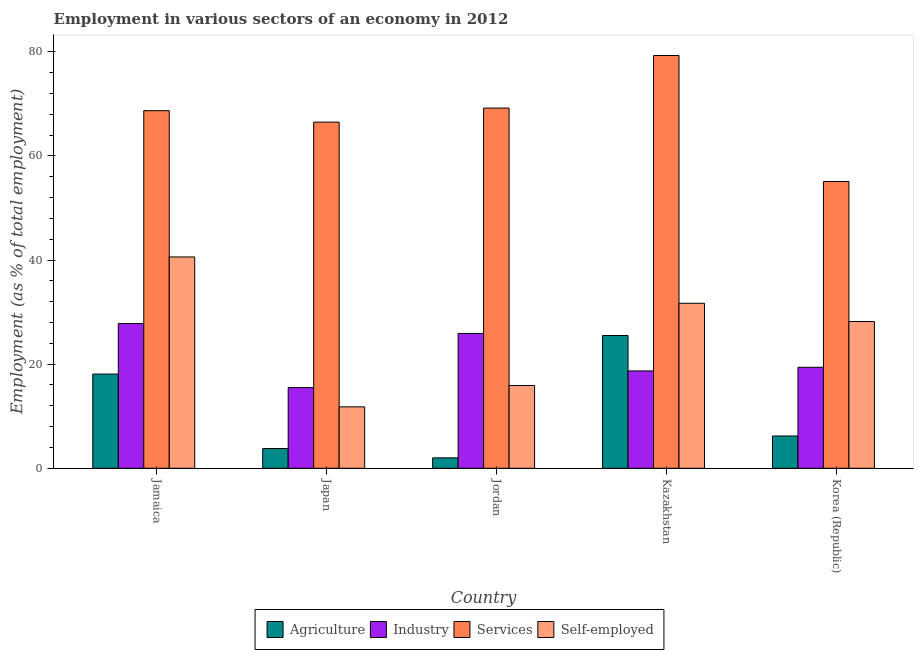How many groups of bars are there?
Keep it short and to the point. 5. Are the number of bars per tick equal to the number of legend labels?
Keep it short and to the point. Yes. How many bars are there on the 5th tick from the right?
Offer a terse response. 4. What is the label of the 1st group of bars from the left?
Make the answer very short. Jamaica. In how many cases, is the number of bars for a given country not equal to the number of legend labels?
Your answer should be compact. 0. What is the percentage of workers in services in Jordan?
Offer a very short reply. 69.2. Across all countries, what is the maximum percentage of workers in services?
Give a very brief answer. 79.3. Across all countries, what is the minimum percentage of workers in industry?
Provide a short and direct response. 15.5. In which country was the percentage of workers in services maximum?
Provide a succinct answer. Kazakhstan. What is the total percentage of self employed workers in the graph?
Your answer should be compact. 128.2. What is the difference between the percentage of workers in industry in Japan and that in Jordan?
Your answer should be compact. -10.4. What is the difference between the percentage of workers in industry in Jordan and the percentage of workers in agriculture in Jamaica?
Your answer should be compact. 7.8. What is the average percentage of self employed workers per country?
Provide a short and direct response. 25.64. What is the difference between the percentage of workers in industry and percentage of workers in agriculture in Japan?
Your response must be concise. 11.7. In how many countries, is the percentage of workers in services greater than 36 %?
Provide a succinct answer. 5. What is the ratio of the percentage of workers in industry in Jamaica to that in Jordan?
Keep it short and to the point. 1.07. What is the difference between the highest and the second highest percentage of self employed workers?
Offer a terse response. 8.9. What is the difference between the highest and the lowest percentage of workers in industry?
Ensure brevity in your answer.  12.3. In how many countries, is the percentage of workers in agriculture greater than the average percentage of workers in agriculture taken over all countries?
Keep it short and to the point. 2. Is the sum of the percentage of workers in industry in Jamaica and Kazakhstan greater than the maximum percentage of self employed workers across all countries?
Keep it short and to the point. Yes. Is it the case that in every country, the sum of the percentage of workers in services and percentage of workers in agriculture is greater than the sum of percentage of self employed workers and percentage of workers in industry?
Offer a very short reply. No. What does the 2nd bar from the left in Japan represents?
Your response must be concise. Industry. What does the 4th bar from the right in Jordan represents?
Ensure brevity in your answer.  Agriculture. Is it the case that in every country, the sum of the percentage of workers in agriculture and percentage of workers in industry is greater than the percentage of workers in services?
Your answer should be very brief. No. How many bars are there?
Offer a terse response. 20. Does the graph contain any zero values?
Make the answer very short. No. Where does the legend appear in the graph?
Make the answer very short. Bottom center. How many legend labels are there?
Make the answer very short. 4. What is the title of the graph?
Provide a succinct answer. Employment in various sectors of an economy in 2012. What is the label or title of the Y-axis?
Your response must be concise. Employment (as % of total employment). What is the Employment (as % of total employment) in Agriculture in Jamaica?
Your answer should be very brief. 18.1. What is the Employment (as % of total employment) of Industry in Jamaica?
Give a very brief answer. 27.8. What is the Employment (as % of total employment) in Services in Jamaica?
Give a very brief answer. 68.7. What is the Employment (as % of total employment) in Self-employed in Jamaica?
Provide a succinct answer. 40.6. What is the Employment (as % of total employment) in Agriculture in Japan?
Ensure brevity in your answer.  3.8. What is the Employment (as % of total employment) of Services in Japan?
Provide a short and direct response. 66.5. What is the Employment (as % of total employment) of Self-employed in Japan?
Make the answer very short. 11.8. What is the Employment (as % of total employment) in Agriculture in Jordan?
Your response must be concise. 2. What is the Employment (as % of total employment) of Industry in Jordan?
Offer a terse response. 25.9. What is the Employment (as % of total employment) in Services in Jordan?
Offer a terse response. 69.2. What is the Employment (as % of total employment) of Self-employed in Jordan?
Provide a succinct answer. 15.9. What is the Employment (as % of total employment) in Industry in Kazakhstan?
Keep it short and to the point. 18.7. What is the Employment (as % of total employment) of Services in Kazakhstan?
Provide a succinct answer. 79.3. What is the Employment (as % of total employment) in Self-employed in Kazakhstan?
Ensure brevity in your answer.  31.7. What is the Employment (as % of total employment) in Agriculture in Korea (Republic)?
Offer a very short reply. 6.2. What is the Employment (as % of total employment) of Industry in Korea (Republic)?
Ensure brevity in your answer.  19.4. What is the Employment (as % of total employment) in Services in Korea (Republic)?
Ensure brevity in your answer.  55.1. What is the Employment (as % of total employment) in Self-employed in Korea (Republic)?
Your response must be concise. 28.2. Across all countries, what is the maximum Employment (as % of total employment) of Industry?
Ensure brevity in your answer.  27.8. Across all countries, what is the maximum Employment (as % of total employment) in Services?
Offer a very short reply. 79.3. Across all countries, what is the maximum Employment (as % of total employment) of Self-employed?
Ensure brevity in your answer.  40.6. Across all countries, what is the minimum Employment (as % of total employment) of Services?
Give a very brief answer. 55.1. Across all countries, what is the minimum Employment (as % of total employment) in Self-employed?
Ensure brevity in your answer.  11.8. What is the total Employment (as % of total employment) of Agriculture in the graph?
Make the answer very short. 55.6. What is the total Employment (as % of total employment) in Industry in the graph?
Give a very brief answer. 107.3. What is the total Employment (as % of total employment) of Services in the graph?
Offer a terse response. 338.8. What is the total Employment (as % of total employment) in Self-employed in the graph?
Provide a succinct answer. 128.2. What is the difference between the Employment (as % of total employment) in Agriculture in Jamaica and that in Japan?
Your response must be concise. 14.3. What is the difference between the Employment (as % of total employment) in Self-employed in Jamaica and that in Japan?
Your answer should be very brief. 28.8. What is the difference between the Employment (as % of total employment) in Agriculture in Jamaica and that in Jordan?
Offer a very short reply. 16.1. What is the difference between the Employment (as % of total employment) of Self-employed in Jamaica and that in Jordan?
Provide a succinct answer. 24.7. What is the difference between the Employment (as % of total employment) of Agriculture in Jamaica and that in Kazakhstan?
Make the answer very short. -7.4. What is the difference between the Employment (as % of total employment) of Industry in Jamaica and that in Kazakhstan?
Make the answer very short. 9.1. What is the difference between the Employment (as % of total employment) of Self-employed in Jamaica and that in Korea (Republic)?
Provide a succinct answer. 12.4. What is the difference between the Employment (as % of total employment) of Services in Japan and that in Jordan?
Keep it short and to the point. -2.7. What is the difference between the Employment (as % of total employment) of Self-employed in Japan and that in Jordan?
Ensure brevity in your answer.  -4.1. What is the difference between the Employment (as % of total employment) in Agriculture in Japan and that in Kazakhstan?
Give a very brief answer. -21.7. What is the difference between the Employment (as % of total employment) of Industry in Japan and that in Kazakhstan?
Offer a terse response. -3.2. What is the difference between the Employment (as % of total employment) in Services in Japan and that in Kazakhstan?
Your answer should be very brief. -12.8. What is the difference between the Employment (as % of total employment) in Self-employed in Japan and that in Kazakhstan?
Offer a very short reply. -19.9. What is the difference between the Employment (as % of total employment) in Agriculture in Japan and that in Korea (Republic)?
Provide a short and direct response. -2.4. What is the difference between the Employment (as % of total employment) of Industry in Japan and that in Korea (Republic)?
Make the answer very short. -3.9. What is the difference between the Employment (as % of total employment) in Self-employed in Japan and that in Korea (Republic)?
Ensure brevity in your answer.  -16.4. What is the difference between the Employment (as % of total employment) in Agriculture in Jordan and that in Kazakhstan?
Keep it short and to the point. -23.5. What is the difference between the Employment (as % of total employment) of Self-employed in Jordan and that in Kazakhstan?
Provide a succinct answer. -15.8. What is the difference between the Employment (as % of total employment) in Agriculture in Jordan and that in Korea (Republic)?
Your answer should be compact. -4.2. What is the difference between the Employment (as % of total employment) in Industry in Jordan and that in Korea (Republic)?
Offer a terse response. 6.5. What is the difference between the Employment (as % of total employment) in Self-employed in Jordan and that in Korea (Republic)?
Offer a very short reply. -12.3. What is the difference between the Employment (as % of total employment) of Agriculture in Kazakhstan and that in Korea (Republic)?
Make the answer very short. 19.3. What is the difference between the Employment (as % of total employment) in Services in Kazakhstan and that in Korea (Republic)?
Your answer should be very brief. 24.2. What is the difference between the Employment (as % of total employment) of Self-employed in Kazakhstan and that in Korea (Republic)?
Offer a very short reply. 3.5. What is the difference between the Employment (as % of total employment) in Agriculture in Jamaica and the Employment (as % of total employment) in Industry in Japan?
Ensure brevity in your answer.  2.6. What is the difference between the Employment (as % of total employment) in Agriculture in Jamaica and the Employment (as % of total employment) in Services in Japan?
Your answer should be compact. -48.4. What is the difference between the Employment (as % of total employment) in Industry in Jamaica and the Employment (as % of total employment) in Services in Japan?
Keep it short and to the point. -38.7. What is the difference between the Employment (as % of total employment) of Industry in Jamaica and the Employment (as % of total employment) of Self-employed in Japan?
Ensure brevity in your answer.  16. What is the difference between the Employment (as % of total employment) in Services in Jamaica and the Employment (as % of total employment) in Self-employed in Japan?
Provide a short and direct response. 56.9. What is the difference between the Employment (as % of total employment) of Agriculture in Jamaica and the Employment (as % of total employment) of Services in Jordan?
Your response must be concise. -51.1. What is the difference between the Employment (as % of total employment) of Agriculture in Jamaica and the Employment (as % of total employment) of Self-employed in Jordan?
Keep it short and to the point. 2.2. What is the difference between the Employment (as % of total employment) in Industry in Jamaica and the Employment (as % of total employment) in Services in Jordan?
Your answer should be compact. -41.4. What is the difference between the Employment (as % of total employment) of Services in Jamaica and the Employment (as % of total employment) of Self-employed in Jordan?
Offer a very short reply. 52.8. What is the difference between the Employment (as % of total employment) in Agriculture in Jamaica and the Employment (as % of total employment) in Industry in Kazakhstan?
Provide a succinct answer. -0.6. What is the difference between the Employment (as % of total employment) in Agriculture in Jamaica and the Employment (as % of total employment) in Services in Kazakhstan?
Your response must be concise. -61.2. What is the difference between the Employment (as % of total employment) of Industry in Jamaica and the Employment (as % of total employment) of Services in Kazakhstan?
Ensure brevity in your answer.  -51.5. What is the difference between the Employment (as % of total employment) in Services in Jamaica and the Employment (as % of total employment) in Self-employed in Kazakhstan?
Your answer should be very brief. 37. What is the difference between the Employment (as % of total employment) of Agriculture in Jamaica and the Employment (as % of total employment) of Services in Korea (Republic)?
Provide a succinct answer. -37. What is the difference between the Employment (as % of total employment) in Agriculture in Jamaica and the Employment (as % of total employment) in Self-employed in Korea (Republic)?
Make the answer very short. -10.1. What is the difference between the Employment (as % of total employment) of Industry in Jamaica and the Employment (as % of total employment) of Services in Korea (Republic)?
Your response must be concise. -27.3. What is the difference between the Employment (as % of total employment) of Services in Jamaica and the Employment (as % of total employment) of Self-employed in Korea (Republic)?
Your answer should be compact. 40.5. What is the difference between the Employment (as % of total employment) in Agriculture in Japan and the Employment (as % of total employment) in Industry in Jordan?
Ensure brevity in your answer.  -22.1. What is the difference between the Employment (as % of total employment) in Agriculture in Japan and the Employment (as % of total employment) in Services in Jordan?
Offer a terse response. -65.4. What is the difference between the Employment (as % of total employment) in Industry in Japan and the Employment (as % of total employment) in Services in Jordan?
Offer a terse response. -53.7. What is the difference between the Employment (as % of total employment) of Industry in Japan and the Employment (as % of total employment) of Self-employed in Jordan?
Provide a succinct answer. -0.4. What is the difference between the Employment (as % of total employment) in Services in Japan and the Employment (as % of total employment) in Self-employed in Jordan?
Provide a short and direct response. 50.6. What is the difference between the Employment (as % of total employment) in Agriculture in Japan and the Employment (as % of total employment) in Industry in Kazakhstan?
Your response must be concise. -14.9. What is the difference between the Employment (as % of total employment) of Agriculture in Japan and the Employment (as % of total employment) of Services in Kazakhstan?
Offer a terse response. -75.5. What is the difference between the Employment (as % of total employment) in Agriculture in Japan and the Employment (as % of total employment) in Self-employed in Kazakhstan?
Make the answer very short. -27.9. What is the difference between the Employment (as % of total employment) in Industry in Japan and the Employment (as % of total employment) in Services in Kazakhstan?
Keep it short and to the point. -63.8. What is the difference between the Employment (as % of total employment) of Industry in Japan and the Employment (as % of total employment) of Self-employed in Kazakhstan?
Keep it short and to the point. -16.2. What is the difference between the Employment (as % of total employment) in Services in Japan and the Employment (as % of total employment) in Self-employed in Kazakhstan?
Your answer should be very brief. 34.8. What is the difference between the Employment (as % of total employment) in Agriculture in Japan and the Employment (as % of total employment) in Industry in Korea (Republic)?
Offer a very short reply. -15.6. What is the difference between the Employment (as % of total employment) in Agriculture in Japan and the Employment (as % of total employment) in Services in Korea (Republic)?
Make the answer very short. -51.3. What is the difference between the Employment (as % of total employment) in Agriculture in Japan and the Employment (as % of total employment) in Self-employed in Korea (Republic)?
Give a very brief answer. -24.4. What is the difference between the Employment (as % of total employment) in Industry in Japan and the Employment (as % of total employment) in Services in Korea (Republic)?
Provide a succinct answer. -39.6. What is the difference between the Employment (as % of total employment) of Services in Japan and the Employment (as % of total employment) of Self-employed in Korea (Republic)?
Make the answer very short. 38.3. What is the difference between the Employment (as % of total employment) in Agriculture in Jordan and the Employment (as % of total employment) in Industry in Kazakhstan?
Your answer should be very brief. -16.7. What is the difference between the Employment (as % of total employment) of Agriculture in Jordan and the Employment (as % of total employment) of Services in Kazakhstan?
Offer a very short reply. -77.3. What is the difference between the Employment (as % of total employment) in Agriculture in Jordan and the Employment (as % of total employment) in Self-employed in Kazakhstan?
Your response must be concise. -29.7. What is the difference between the Employment (as % of total employment) in Industry in Jordan and the Employment (as % of total employment) in Services in Kazakhstan?
Keep it short and to the point. -53.4. What is the difference between the Employment (as % of total employment) of Services in Jordan and the Employment (as % of total employment) of Self-employed in Kazakhstan?
Provide a succinct answer. 37.5. What is the difference between the Employment (as % of total employment) in Agriculture in Jordan and the Employment (as % of total employment) in Industry in Korea (Republic)?
Your answer should be very brief. -17.4. What is the difference between the Employment (as % of total employment) in Agriculture in Jordan and the Employment (as % of total employment) in Services in Korea (Republic)?
Make the answer very short. -53.1. What is the difference between the Employment (as % of total employment) in Agriculture in Jordan and the Employment (as % of total employment) in Self-employed in Korea (Republic)?
Your response must be concise. -26.2. What is the difference between the Employment (as % of total employment) in Industry in Jordan and the Employment (as % of total employment) in Services in Korea (Republic)?
Your answer should be very brief. -29.2. What is the difference between the Employment (as % of total employment) of Agriculture in Kazakhstan and the Employment (as % of total employment) of Services in Korea (Republic)?
Give a very brief answer. -29.6. What is the difference between the Employment (as % of total employment) of Industry in Kazakhstan and the Employment (as % of total employment) of Services in Korea (Republic)?
Provide a succinct answer. -36.4. What is the difference between the Employment (as % of total employment) of Industry in Kazakhstan and the Employment (as % of total employment) of Self-employed in Korea (Republic)?
Your answer should be compact. -9.5. What is the difference between the Employment (as % of total employment) of Services in Kazakhstan and the Employment (as % of total employment) of Self-employed in Korea (Republic)?
Offer a terse response. 51.1. What is the average Employment (as % of total employment) in Agriculture per country?
Offer a very short reply. 11.12. What is the average Employment (as % of total employment) of Industry per country?
Your response must be concise. 21.46. What is the average Employment (as % of total employment) of Services per country?
Your response must be concise. 67.76. What is the average Employment (as % of total employment) of Self-employed per country?
Provide a succinct answer. 25.64. What is the difference between the Employment (as % of total employment) in Agriculture and Employment (as % of total employment) in Industry in Jamaica?
Ensure brevity in your answer.  -9.7. What is the difference between the Employment (as % of total employment) in Agriculture and Employment (as % of total employment) in Services in Jamaica?
Your answer should be very brief. -50.6. What is the difference between the Employment (as % of total employment) of Agriculture and Employment (as % of total employment) of Self-employed in Jamaica?
Offer a terse response. -22.5. What is the difference between the Employment (as % of total employment) of Industry and Employment (as % of total employment) of Services in Jamaica?
Give a very brief answer. -40.9. What is the difference between the Employment (as % of total employment) in Industry and Employment (as % of total employment) in Self-employed in Jamaica?
Offer a very short reply. -12.8. What is the difference between the Employment (as % of total employment) of Services and Employment (as % of total employment) of Self-employed in Jamaica?
Your answer should be very brief. 28.1. What is the difference between the Employment (as % of total employment) in Agriculture and Employment (as % of total employment) in Services in Japan?
Keep it short and to the point. -62.7. What is the difference between the Employment (as % of total employment) in Industry and Employment (as % of total employment) in Services in Japan?
Ensure brevity in your answer.  -51. What is the difference between the Employment (as % of total employment) in Industry and Employment (as % of total employment) in Self-employed in Japan?
Ensure brevity in your answer.  3.7. What is the difference between the Employment (as % of total employment) in Services and Employment (as % of total employment) in Self-employed in Japan?
Give a very brief answer. 54.7. What is the difference between the Employment (as % of total employment) in Agriculture and Employment (as % of total employment) in Industry in Jordan?
Provide a succinct answer. -23.9. What is the difference between the Employment (as % of total employment) in Agriculture and Employment (as % of total employment) in Services in Jordan?
Give a very brief answer. -67.2. What is the difference between the Employment (as % of total employment) of Industry and Employment (as % of total employment) of Services in Jordan?
Keep it short and to the point. -43.3. What is the difference between the Employment (as % of total employment) in Industry and Employment (as % of total employment) in Self-employed in Jordan?
Your answer should be compact. 10. What is the difference between the Employment (as % of total employment) of Services and Employment (as % of total employment) of Self-employed in Jordan?
Provide a succinct answer. 53.3. What is the difference between the Employment (as % of total employment) in Agriculture and Employment (as % of total employment) in Industry in Kazakhstan?
Provide a succinct answer. 6.8. What is the difference between the Employment (as % of total employment) in Agriculture and Employment (as % of total employment) in Services in Kazakhstan?
Ensure brevity in your answer.  -53.8. What is the difference between the Employment (as % of total employment) of Agriculture and Employment (as % of total employment) of Self-employed in Kazakhstan?
Offer a very short reply. -6.2. What is the difference between the Employment (as % of total employment) in Industry and Employment (as % of total employment) in Services in Kazakhstan?
Provide a succinct answer. -60.6. What is the difference between the Employment (as % of total employment) of Services and Employment (as % of total employment) of Self-employed in Kazakhstan?
Keep it short and to the point. 47.6. What is the difference between the Employment (as % of total employment) of Agriculture and Employment (as % of total employment) of Industry in Korea (Republic)?
Give a very brief answer. -13.2. What is the difference between the Employment (as % of total employment) of Agriculture and Employment (as % of total employment) of Services in Korea (Republic)?
Provide a succinct answer. -48.9. What is the difference between the Employment (as % of total employment) of Agriculture and Employment (as % of total employment) of Self-employed in Korea (Republic)?
Your answer should be compact. -22. What is the difference between the Employment (as % of total employment) of Industry and Employment (as % of total employment) of Services in Korea (Republic)?
Offer a terse response. -35.7. What is the difference between the Employment (as % of total employment) of Industry and Employment (as % of total employment) of Self-employed in Korea (Republic)?
Your answer should be compact. -8.8. What is the difference between the Employment (as % of total employment) in Services and Employment (as % of total employment) in Self-employed in Korea (Republic)?
Your answer should be compact. 26.9. What is the ratio of the Employment (as % of total employment) in Agriculture in Jamaica to that in Japan?
Make the answer very short. 4.76. What is the ratio of the Employment (as % of total employment) in Industry in Jamaica to that in Japan?
Your answer should be compact. 1.79. What is the ratio of the Employment (as % of total employment) of Services in Jamaica to that in Japan?
Your answer should be very brief. 1.03. What is the ratio of the Employment (as % of total employment) in Self-employed in Jamaica to that in Japan?
Provide a short and direct response. 3.44. What is the ratio of the Employment (as % of total employment) in Agriculture in Jamaica to that in Jordan?
Provide a short and direct response. 9.05. What is the ratio of the Employment (as % of total employment) of Industry in Jamaica to that in Jordan?
Your answer should be very brief. 1.07. What is the ratio of the Employment (as % of total employment) in Self-employed in Jamaica to that in Jordan?
Your answer should be compact. 2.55. What is the ratio of the Employment (as % of total employment) of Agriculture in Jamaica to that in Kazakhstan?
Give a very brief answer. 0.71. What is the ratio of the Employment (as % of total employment) of Industry in Jamaica to that in Kazakhstan?
Provide a succinct answer. 1.49. What is the ratio of the Employment (as % of total employment) in Services in Jamaica to that in Kazakhstan?
Make the answer very short. 0.87. What is the ratio of the Employment (as % of total employment) in Self-employed in Jamaica to that in Kazakhstan?
Give a very brief answer. 1.28. What is the ratio of the Employment (as % of total employment) of Agriculture in Jamaica to that in Korea (Republic)?
Give a very brief answer. 2.92. What is the ratio of the Employment (as % of total employment) of Industry in Jamaica to that in Korea (Republic)?
Provide a short and direct response. 1.43. What is the ratio of the Employment (as % of total employment) of Services in Jamaica to that in Korea (Republic)?
Your answer should be compact. 1.25. What is the ratio of the Employment (as % of total employment) in Self-employed in Jamaica to that in Korea (Republic)?
Provide a short and direct response. 1.44. What is the ratio of the Employment (as % of total employment) of Agriculture in Japan to that in Jordan?
Keep it short and to the point. 1.9. What is the ratio of the Employment (as % of total employment) in Industry in Japan to that in Jordan?
Provide a succinct answer. 0.6. What is the ratio of the Employment (as % of total employment) of Self-employed in Japan to that in Jordan?
Make the answer very short. 0.74. What is the ratio of the Employment (as % of total employment) of Agriculture in Japan to that in Kazakhstan?
Ensure brevity in your answer.  0.15. What is the ratio of the Employment (as % of total employment) of Industry in Japan to that in Kazakhstan?
Offer a terse response. 0.83. What is the ratio of the Employment (as % of total employment) of Services in Japan to that in Kazakhstan?
Your answer should be compact. 0.84. What is the ratio of the Employment (as % of total employment) in Self-employed in Japan to that in Kazakhstan?
Your answer should be very brief. 0.37. What is the ratio of the Employment (as % of total employment) of Agriculture in Japan to that in Korea (Republic)?
Provide a succinct answer. 0.61. What is the ratio of the Employment (as % of total employment) of Industry in Japan to that in Korea (Republic)?
Make the answer very short. 0.8. What is the ratio of the Employment (as % of total employment) in Services in Japan to that in Korea (Republic)?
Give a very brief answer. 1.21. What is the ratio of the Employment (as % of total employment) of Self-employed in Japan to that in Korea (Republic)?
Provide a short and direct response. 0.42. What is the ratio of the Employment (as % of total employment) of Agriculture in Jordan to that in Kazakhstan?
Offer a terse response. 0.08. What is the ratio of the Employment (as % of total employment) of Industry in Jordan to that in Kazakhstan?
Make the answer very short. 1.39. What is the ratio of the Employment (as % of total employment) in Services in Jordan to that in Kazakhstan?
Your answer should be very brief. 0.87. What is the ratio of the Employment (as % of total employment) in Self-employed in Jordan to that in Kazakhstan?
Offer a terse response. 0.5. What is the ratio of the Employment (as % of total employment) in Agriculture in Jordan to that in Korea (Republic)?
Provide a short and direct response. 0.32. What is the ratio of the Employment (as % of total employment) of Industry in Jordan to that in Korea (Republic)?
Offer a very short reply. 1.34. What is the ratio of the Employment (as % of total employment) of Services in Jordan to that in Korea (Republic)?
Provide a short and direct response. 1.26. What is the ratio of the Employment (as % of total employment) in Self-employed in Jordan to that in Korea (Republic)?
Make the answer very short. 0.56. What is the ratio of the Employment (as % of total employment) in Agriculture in Kazakhstan to that in Korea (Republic)?
Give a very brief answer. 4.11. What is the ratio of the Employment (as % of total employment) in Industry in Kazakhstan to that in Korea (Republic)?
Your response must be concise. 0.96. What is the ratio of the Employment (as % of total employment) in Services in Kazakhstan to that in Korea (Republic)?
Your answer should be compact. 1.44. What is the ratio of the Employment (as % of total employment) in Self-employed in Kazakhstan to that in Korea (Republic)?
Provide a short and direct response. 1.12. What is the difference between the highest and the second highest Employment (as % of total employment) of Agriculture?
Ensure brevity in your answer.  7.4. What is the difference between the highest and the second highest Employment (as % of total employment) of Self-employed?
Ensure brevity in your answer.  8.9. What is the difference between the highest and the lowest Employment (as % of total employment) in Industry?
Ensure brevity in your answer.  12.3. What is the difference between the highest and the lowest Employment (as % of total employment) in Services?
Offer a very short reply. 24.2. What is the difference between the highest and the lowest Employment (as % of total employment) in Self-employed?
Your response must be concise. 28.8. 